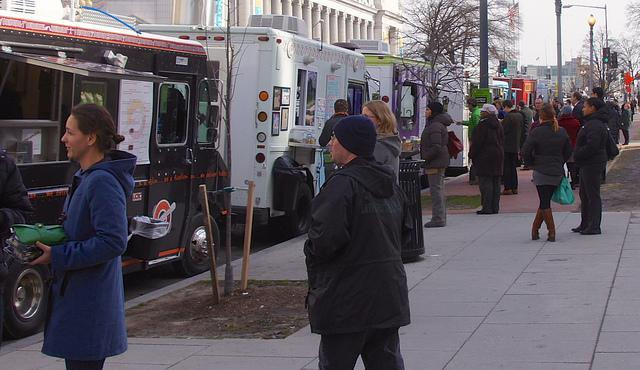What is the color of second vehicle? white 